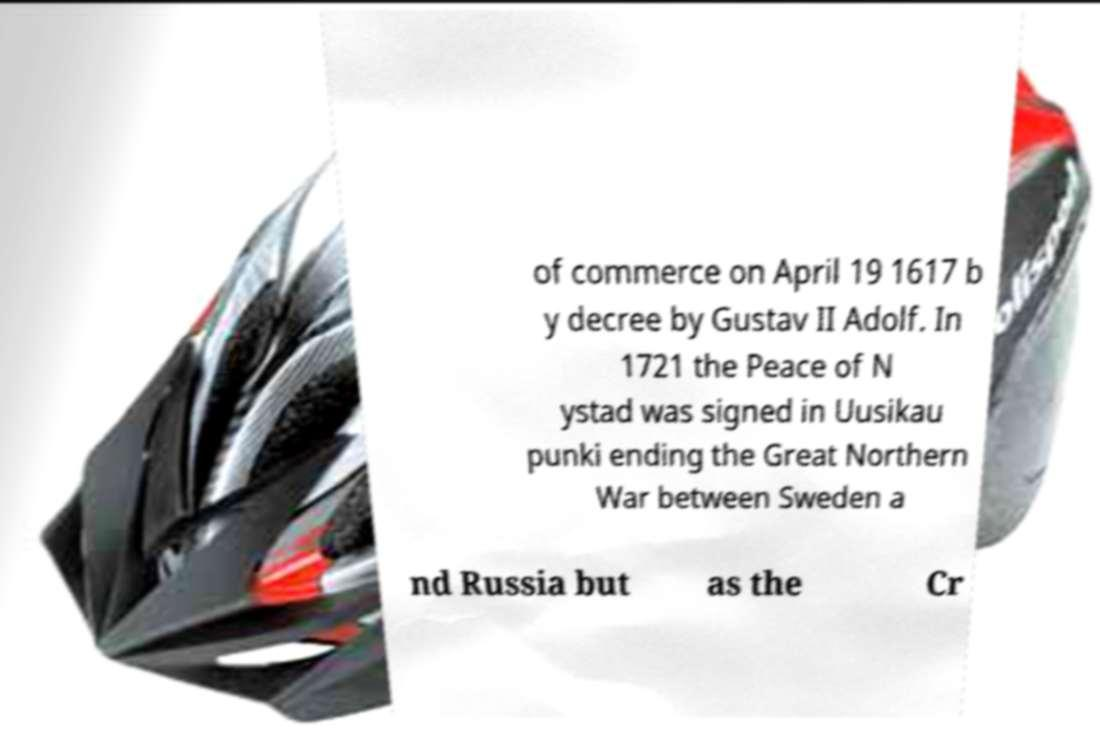Please read and relay the text visible in this image. What does it say? of commerce on April 19 1617 b y decree by Gustav II Adolf. In 1721 the Peace of N ystad was signed in Uusikau punki ending the Great Northern War between Sweden a nd Russia but as the Cr 